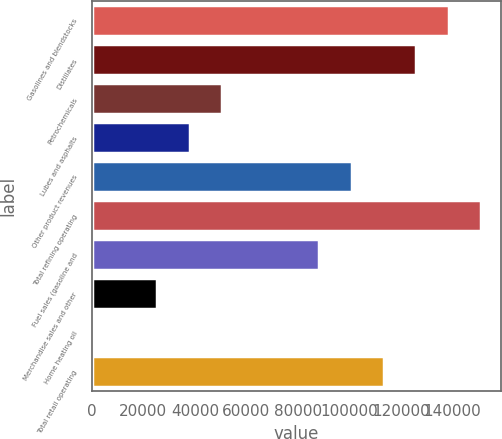<chart> <loc_0><loc_0><loc_500><loc_500><bar_chart><fcel>Gasolines and blendstocks<fcel>Distillates<fcel>Petrochemicals<fcel>Lubes and asphalts<fcel>Other product revenues<fcel>Total refining operating<fcel>Fuel sales (gasoline and<fcel>Merchandise sales and other<fcel>Home heating oil<fcel>Total retail operating<nl><fcel>138552<fcel>125987<fcel>50595.2<fcel>38029.9<fcel>100856<fcel>151118<fcel>88291.1<fcel>25464.6<fcel>334<fcel>113422<nl></chart> 